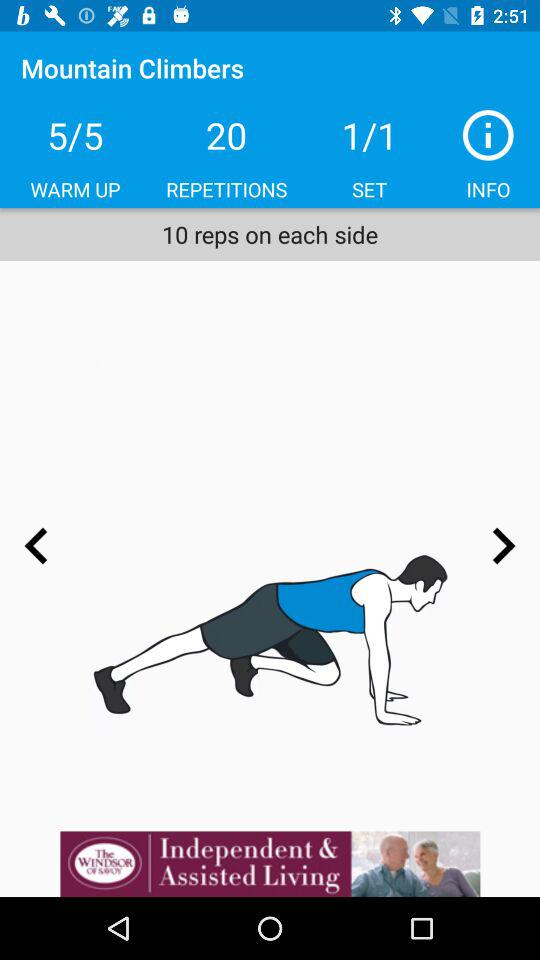How many total warm-up exercises are there? The total warm-up exercises are 5. 